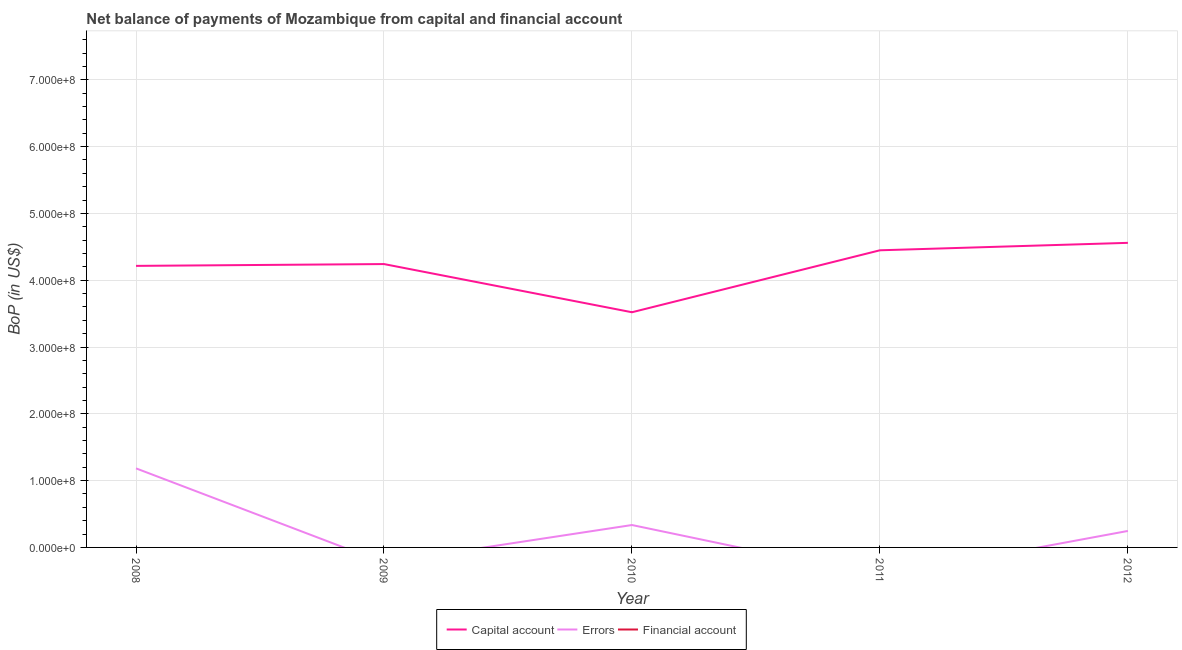How many different coloured lines are there?
Your answer should be very brief. 2. Across all years, what is the maximum amount of errors?
Your answer should be very brief. 1.18e+08. What is the difference between the amount of errors in 2008 and that in 2010?
Keep it short and to the point. 8.48e+07. What is the difference between the amount of net capital account in 2008 and the amount of financial account in 2010?
Provide a short and direct response. 4.21e+08. What is the ratio of the amount of net capital account in 2008 to that in 2011?
Keep it short and to the point. 0.95. Is the amount of net capital account in 2008 less than that in 2010?
Make the answer very short. No. What is the difference between the highest and the second highest amount of net capital account?
Make the answer very short. 1.11e+07. What is the difference between the highest and the lowest amount of errors?
Provide a succinct answer. 1.18e+08. Is the sum of the amount of net capital account in 2008 and 2010 greater than the maximum amount of errors across all years?
Make the answer very short. Yes. Is it the case that in every year, the sum of the amount of net capital account and amount of errors is greater than the amount of financial account?
Provide a short and direct response. Yes. Is the amount of errors strictly greater than the amount of net capital account over the years?
Give a very brief answer. No. How many lines are there?
Your answer should be compact. 2. How many years are there in the graph?
Provide a short and direct response. 5. What is the difference between two consecutive major ticks on the Y-axis?
Ensure brevity in your answer.  1.00e+08. How many legend labels are there?
Provide a short and direct response. 3. What is the title of the graph?
Provide a short and direct response. Net balance of payments of Mozambique from capital and financial account. Does "Domestic economy" appear as one of the legend labels in the graph?
Make the answer very short. No. What is the label or title of the Y-axis?
Your answer should be compact. BoP (in US$). What is the BoP (in US$) in Capital account in 2008?
Provide a short and direct response. 4.21e+08. What is the BoP (in US$) of Errors in 2008?
Offer a very short reply. 1.18e+08. What is the BoP (in US$) in Capital account in 2009?
Make the answer very short. 4.24e+08. What is the BoP (in US$) of Capital account in 2010?
Give a very brief answer. 3.52e+08. What is the BoP (in US$) in Errors in 2010?
Provide a short and direct response. 3.35e+07. What is the BoP (in US$) of Capital account in 2011?
Your answer should be compact. 4.45e+08. What is the BoP (in US$) in Errors in 2011?
Your answer should be very brief. 0. What is the BoP (in US$) of Capital account in 2012?
Give a very brief answer. 4.56e+08. What is the BoP (in US$) of Errors in 2012?
Give a very brief answer. 2.47e+07. What is the BoP (in US$) in Financial account in 2012?
Offer a very short reply. 0. Across all years, what is the maximum BoP (in US$) of Capital account?
Ensure brevity in your answer.  4.56e+08. Across all years, what is the maximum BoP (in US$) of Errors?
Give a very brief answer. 1.18e+08. Across all years, what is the minimum BoP (in US$) in Capital account?
Provide a short and direct response. 3.52e+08. Across all years, what is the minimum BoP (in US$) of Errors?
Provide a short and direct response. 0. What is the total BoP (in US$) in Capital account in the graph?
Make the answer very short. 2.10e+09. What is the total BoP (in US$) in Errors in the graph?
Give a very brief answer. 1.77e+08. What is the difference between the BoP (in US$) in Capital account in 2008 and that in 2009?
Make the answer very short. -2.73e+06. What is the difference between the BoP (in US$) of Capital account in 2008 and that in 2010?
Keep it short and to the point. 6.94e+07. What is the difference between the BoP (in US$) in Errors in 2008 and that in 2010?
Provide a short and direct response. 8.48e+07. What is the difference between the BoP (in US$) in Capital account in 2008 and that in 2011?
Your response must be concise. -2.33e+07. What is the difference between the BoP (in US$) in Capital account in 2008 and that in 2012?
Offer a very short reply. -3.45e+07. What is the difference between the BoP (in US$) in Errors in 2008 and that in 2012?
Your response must be concise. 9.37e+07. What is the difference between the BoP (in US$) in Capital account in 2009 and that in 2010?
Offer a terse response. 7.21e+07. What is the difference between the BoP (in US$) of Capital account in 2009 and that in 2011?
Your response must be concise. -2.06e+07. What is the difference between the BoP (in US$) of Capital account in 2009 and that in 2012?
Offer a very short reply. -3.18e+07. What is the difference between the BoP (in US$) of Capital account in 2010 and that in 2011?
Your answer should be compact. -9.28e+07. What is the difference between the BoP (in US$) of Capital account in 2010 and that in 2012?
Offer a very short reply. -1.04e+08. What is the difference between the BoP (in US$) in Errors in 2010 and that in 2012?
Your response must be concise. 8.85e+06. What is the difference between the BoP (in US$) in Capital account in 2011 and that in 2012?
Your answer should be compact. -1.11e+07. What is the difference between the BoP (in US$) of Capital account in 2008 and the BoP (in US$) of Errors in 2010?
Make the answer very short. 3.88e+08. What is the difference between the BoP (in US$) of Capital account in 2008 and the BoP (in US$) of Errors in 2012?
Provide a short and direct response. 3.97e+08. What is the difference between the BoP (in US$) in Capital account in 2009 and the BoP (in US$) in Errors in 2010?
Keep it short and to the point. 3.91e+08. What is the difference between the BoP (in US$) of Capital account in 2009 and the BoP (in US$) of Errors in 2012?
Offer a terse response. 4.00e+08. What is the difference between the BoP (in US$) of Capital account in 2010 and the BoP (in US$) of Errors in 2012?
Make the answer very short. 3.27e+08. What is the difference between the BoP (in US$) of Capital account in 2011 and the BoP (in US$) of Errors in 2012?
Provide a succinct answer. 4.20e+08. What is the average BoP (in US$) of Capital account per year?
Your response must be concise. 4.20e+08. What is the average BoP (in US$) in Errors per year?
Offer a terse response. 3.53e+07. What is the average BoP (in US$) of Financial account per year?
Your response must be concise. 0. In the year 2008, what is the difference between the BoP (in US$) of Capital account and BoP (in US$) of Errors?
Keep it short and to the point. 3.03e+08. In the year 2010, what is the difference between the BoP (in US$) in Capital account and BoP (in US$) in Errors?
Provide a short and direct response. 3.19e+08. In the year 2012, what is the difference between the BoP (in US$) in Capital account and BoP (in US$) in Errors?
Your answer should be very brief. 4.31e+08. What is the ratio of the BoP (in US$) of Capital account in 2008 to that in 2009?
Your answer should be compact. 0.99. What is the ratio of the BoP (in US$) in Capital account in 2008 to that in 2010?
Ensure brevity in your answer.  1.2. What is the ratio of the BoP (in US$) of Errors in 2008 to that in 2010?
Provide a succinct answer. 3.53. What is the ratio of the BoP (in US$) in Capital account in 2008 to that in 2011?
Provide a succinct answer. 0.95. What is the ratio of the BoP (in US$) of Capital account in 2008 to that in 2012?
Give a very brief answer. 0.92. What is the ratio of the BoP (in US$) of Errors in 2008 to that in 2012?
Offer a very short reply. 4.79. What is the ratio of the BoP (in US$) in Capital account in 2009 to that in 2010?
Keep it short and to the point. 1.2. What is the ratio of the BoP (in US$) in Capital account in 2009 to that in 2011?
Provide a short and direct response. 0.95. What is the ratio of the BoP (in US$) of Capital account in 2009 to that in 2012?
Provide a short and direct response. 0.93. What is the ratio of the BoP (in US$) of Capital account in 2010 to that in 2011?
Your response must be concise. 0.79. What is the ratio of the BoP (in US$) of Capital account in 2010 to that in 2012?
Your response must be concise. 0.77. What is the ratio of the BoP (in US$) in Errors in 2010 to that in 2012?
Offer a very short reply. 1.36. What is the ratio of the BoP (in US$) in Capital account in 2011 to that in 2012?
Your answer should be compact. 0.98. What is the difference between the highest and the second highest BoP (in US$) in Capital account?
Provide a succinct answer. 1.11e+07. What is the difference between the highest and the second highest BoP (in US$) of Errors?
Make the answer very short. 8.48e+07. What is the difference between the highest and the lowest BoP (in US$) in Capital account?
Keep it short and to the point. 1.04e+08. What is the difference between the highest and the lowest BoP (in US$) of Errors?
Your answer should be very brief. 1.18e+08. 